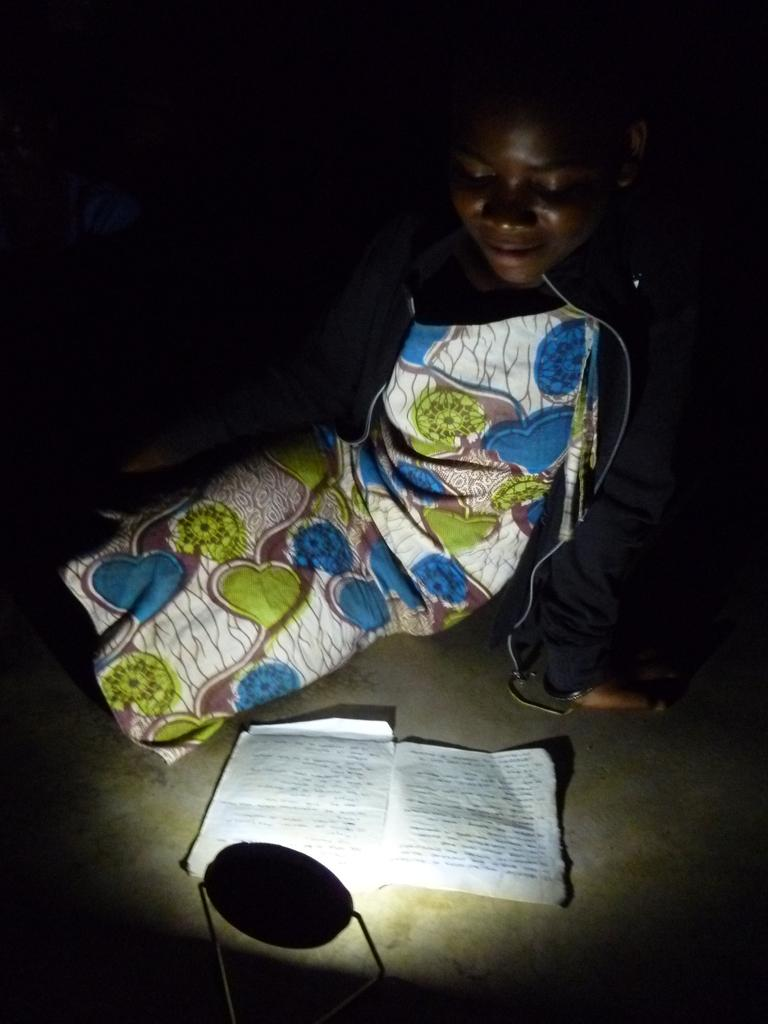What is the main subject of the image? The main subject of the image is a kid. What is the kid wearing in the image? The kid is wearing clothes in the image. What object can be seen besides the kid? There is a book in the image. What source of illumination is present in the image? There is a light in the image. What type of quiver can be seen on the kid's back in the image? There is no quiver present on the kid's back in the image. What level of knowledge does the kid possess, as indicated by the book in the image? The level of knowledge the kid possesses cannot be determined from the image, as it only shows a kid with a book and does not provide any information about the content of the book or the kid's understanding of it. 